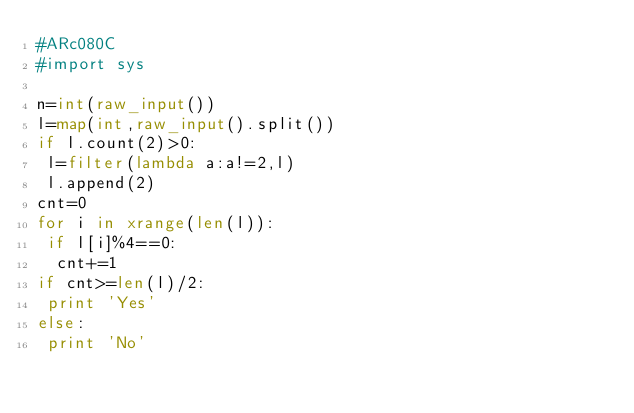Convert code to text. <code><loc_0><loc_0><loc_500><loc_500><_Python_>#ARc080C
#import sys

n=int(raw_input())
l=map(int,raw_input().split())
if l.count(2)>0:
 l=filter(lambda a:a!=2,l)
 l.append(2)
cnt=0
for i in xrange(len(l)):
 if l[i]%4==0:
  cnt+=1
if cnt>=len(l)/2:
 print 'Yes'
else:
 print 'No'
</code> 